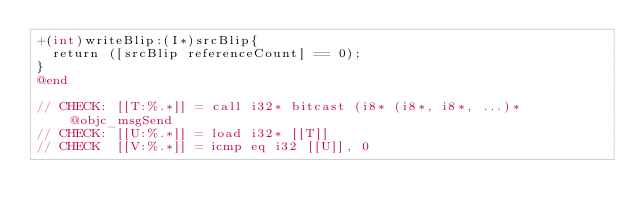<code> <loc_0><loc_0><loc_500><loc_500><_ObjectiveC_>+(int)writeBlip:(I*)srcBlip{
  return ([srcBlip referenceCount] == 0);
}
@end

// CHECK: [[T:%.*]] = call i32* bitcast (i8* (i8*, i8*, ...)* @objc_msgSend
// CHECK: [[U:%.*]] = load i32* [[T]]
// CHECK  [[V:%.*]] = icmp eq i32 [[U]], 0
</code> 